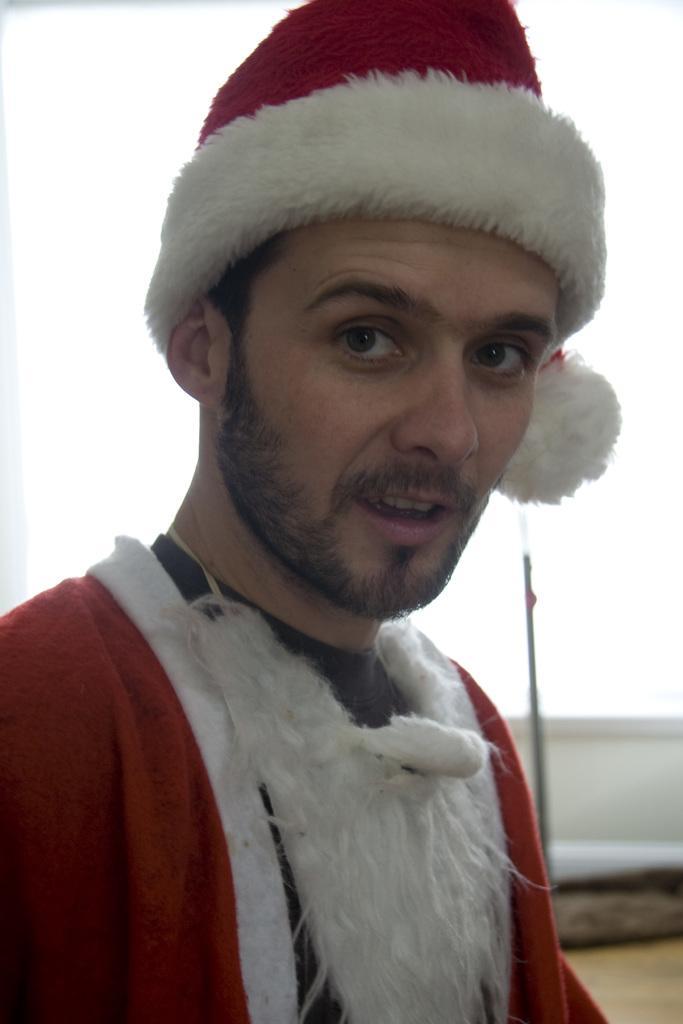Please provide a concise description of this image. In this picture I can observe a man in the middle of the picture. He is wearing red and white color dress along with a cap on his head. The background is blurred. 